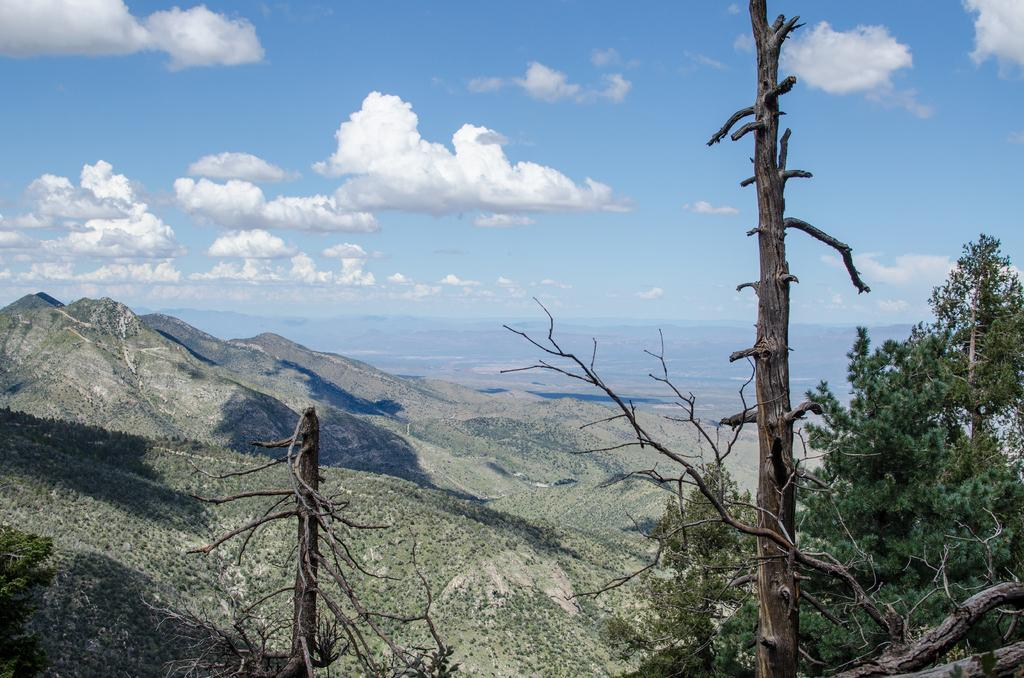What type of natural environment is depicted in the image? The image features many trees and mountains, indicating a natural environment. Can you describe the sky in the image? The sky is cloudy in the image. How many geese are flying over the mountains in the image? There are no geese visible in the image; it only features trees, mountains, and a cloudy sky. Is there a clubhouse located near the mountains in the image? There is no mention of a clubhouse or any man-made structures in the image, only trees, mountains, and a cloudy sky. 